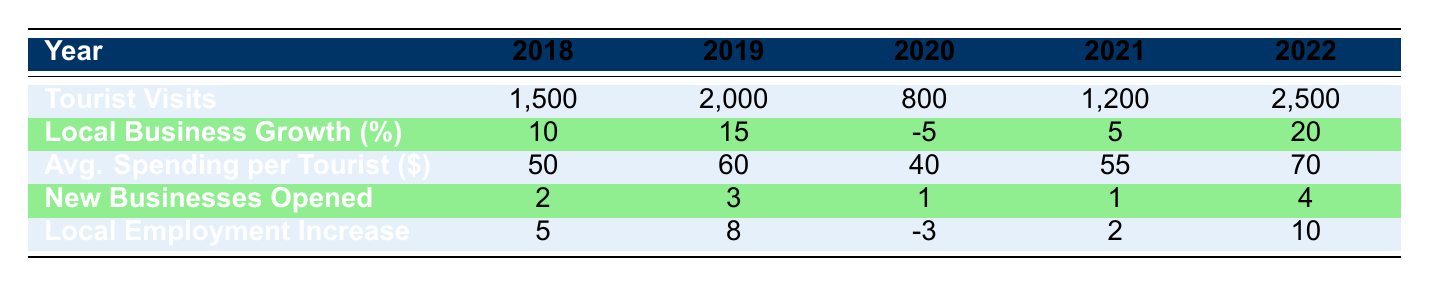What was the highest number of tourist visits in a single year? The maximum number of tourist visits recorded in the table is 2500 in the year 2022.
Answer: 2500 In which year did local business growth reach a negative value? Local business growth was negative in 2020, where it decreased by 5%.
Answer: 2020 What was the total number of new businesses opened from 2018 to 2022? Adding the number of new businesses opened each year: 2 (2018) + 3 (2019) + 1 (2020) + 1 (2021) + 4 (2022) equals 11.
Answer: 11 Did the average spending per tourist increase or decrease from 2019 to 2020? In 2019, the average spending per tourist was 60, and in 2020 it decreased to 40, indicating a decrease.
Answer: Decrease What is the percentage increase in local employment from 2021 to 2022? Local employment increased by 2 in 2021 and by 10 in 2022. The increase is 10 - 2 = 8. The percentage increase is (8 / 2) * 100 = 400%.
Answer: 400% Which year had the lowest average spending per tourist? The year with the lowest average spending per tourist was 2020, with an average of 40 dollars.
Answer: 2020 How many local business growth percentages were above 0% from 2018 to 2022? The years with positive local business growth percentages are 2018 (10%), 2019 (15%), 2021 (5%), and 2022 (20%). Hence, there are four years where growth was above 0%.
Answer: 4 What was the average number of tourist visits per year from 2018 to 2022? The sum of tourist visits over the years is 1500 + 2000 + 800 + 1200 + 2500 = 8000. Dividing by 5, the average is 8000 / 5 = 1600.
Answer: 1600 In which year were the fewest new businesses opened? The fewest new businesses were opened in 2020 and 2021, each with 1 new business.
Answer: 2020 and 2021 